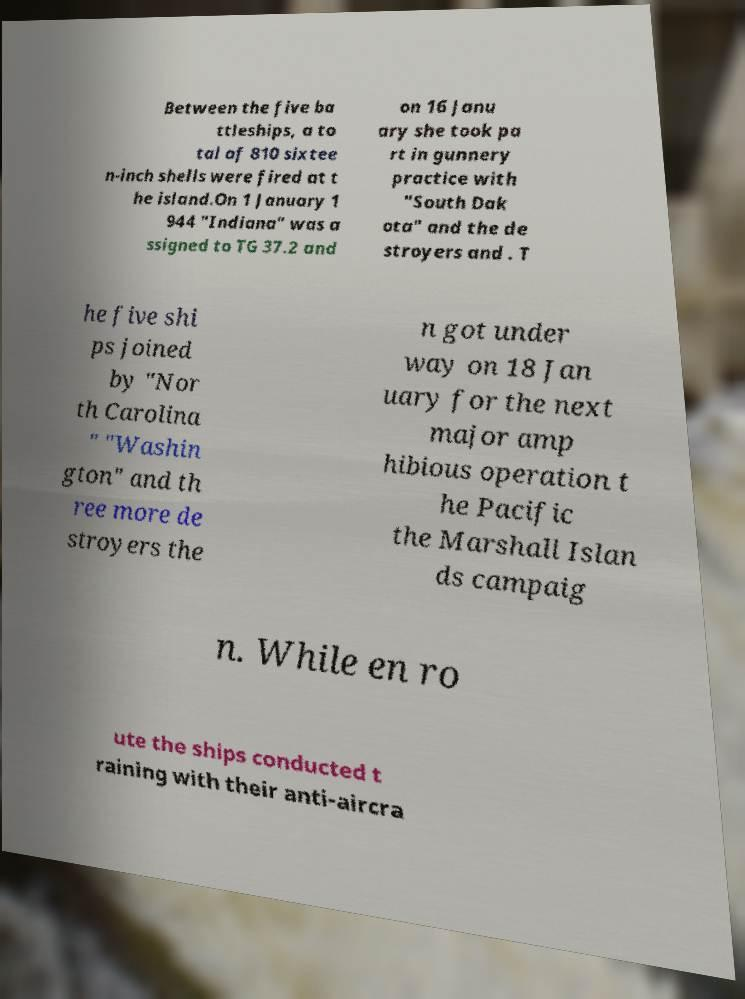I need the written content from this picture converted into text. Can you do that? Between the five ba ttleships, a to tal of 810 sixtee n-inch shells were fired at t he island.On 1 January 1 944 "Indiana" was a ssigned to TG 37.2 and on 16 Janu ary she took pa rt in gunnery practice with "South Dak ota" and the de stroyers and . T he five shi ps joined by "Nor th Carolina " "Washin gton" and th ree more de stroyers the n got under way on 18 Jan uary for the next major amp hibious operation t he Pacific the Marshall Islan ds campaig n. While en ro ute the ships conducted t raining with their anti-aircra 